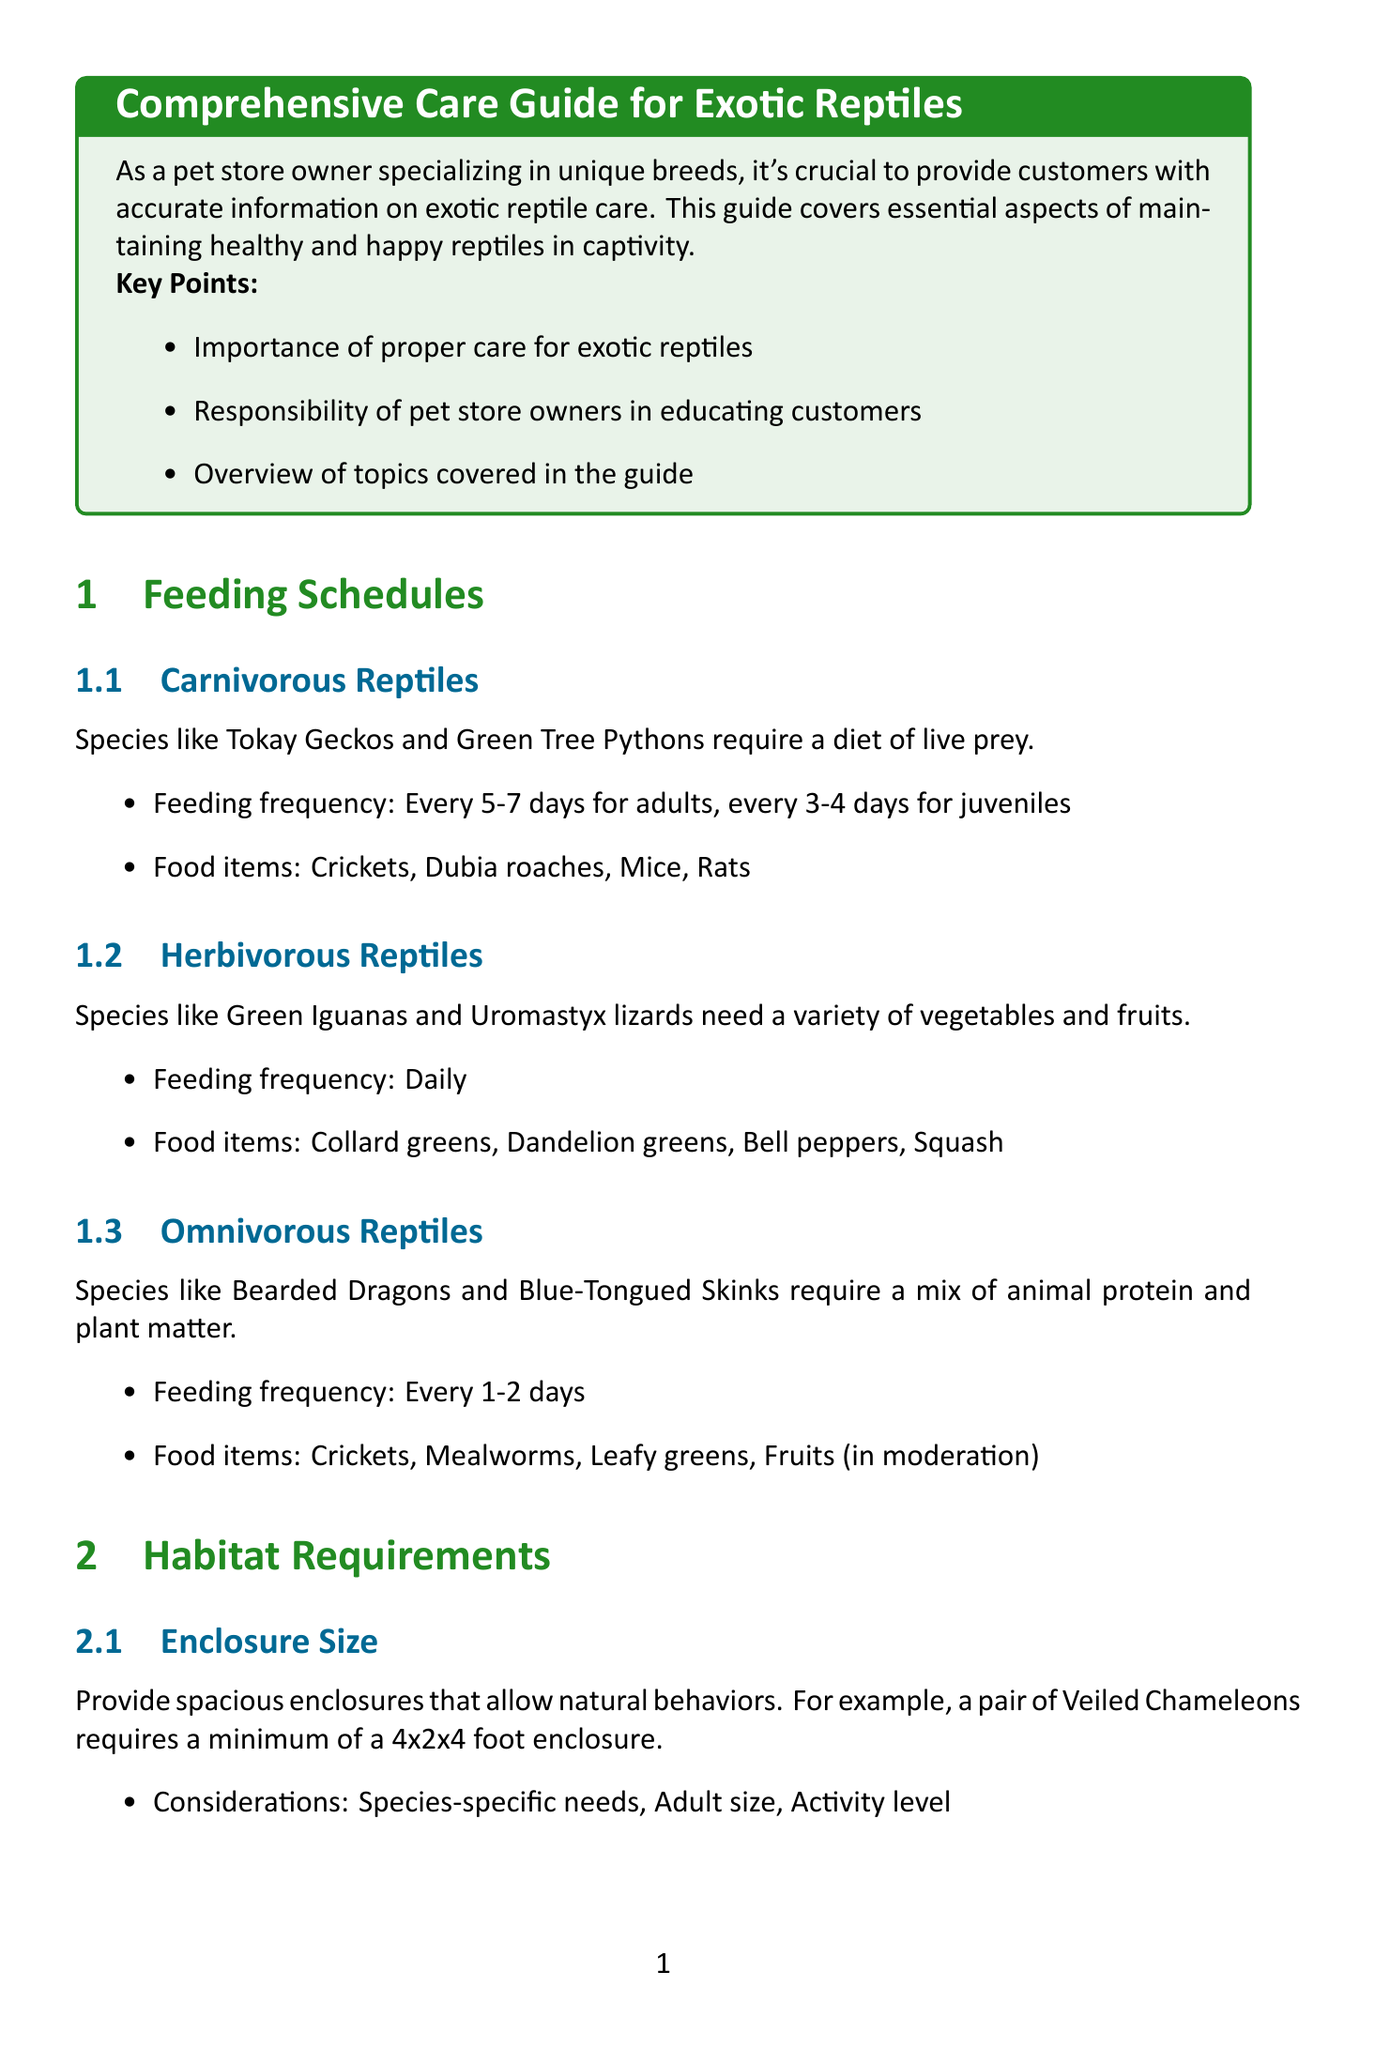what is the feeding frequency for adult carnivorous reptiles? The feeding frequency for adult carnivorous reptiles is specified in the document as every 5-7 days.
Answer: Every 5-7 days what types of food are recommended for herbivorous reptiles? The document lists the food items recommended for herbivorous reptiles, which include collard greens, dandelion greens, bell peppers, and squash.
Answer: Collard greens, dandelion greens, bell peppers, squash what is the minimum enclosure size for a pair of Veiled Chameleons? The minimum enclosure size for a pair of Veiled Chameleons is detailed in the document, stating it requires a minimum of a 4x2x4 foot enclosure.
Answer: 4x2x4 foot how often should reptiles be visually inspected? The document states that reptiles should be visually inspected daily as part of regular health monitoring.
Answer: Daily what humidity level do Ball Pythons require? The document specifies that Ball Pythons require a humidity level of 50-60%.
Answer: 50-60% what are some shedding aids mentioned in the document? The shedding aids listed in the document include moist hide boxes, rough bark or rocks, and warm soaks (if necessary).
Answer: Moist hide boxes, rough bark or rocks, warm soaks how often do omnivorous reptiles need to be fed? The document indicates that omnivorous reptiles should be fed every 1-2 days.
Answer: Every 1-2 days what type of lighting is recommended for Bearded Dragons? The document recommends providing UVB lighting for Bearded Dragons.
Answer: UVB lighting what is one key takeaway from the conclusion of the document? The conclusion of the document includes several key takeaways, one of which highlights the importance of tailoring care to each species' specific needs.
Answer: Tailor care to each species' specific needs 